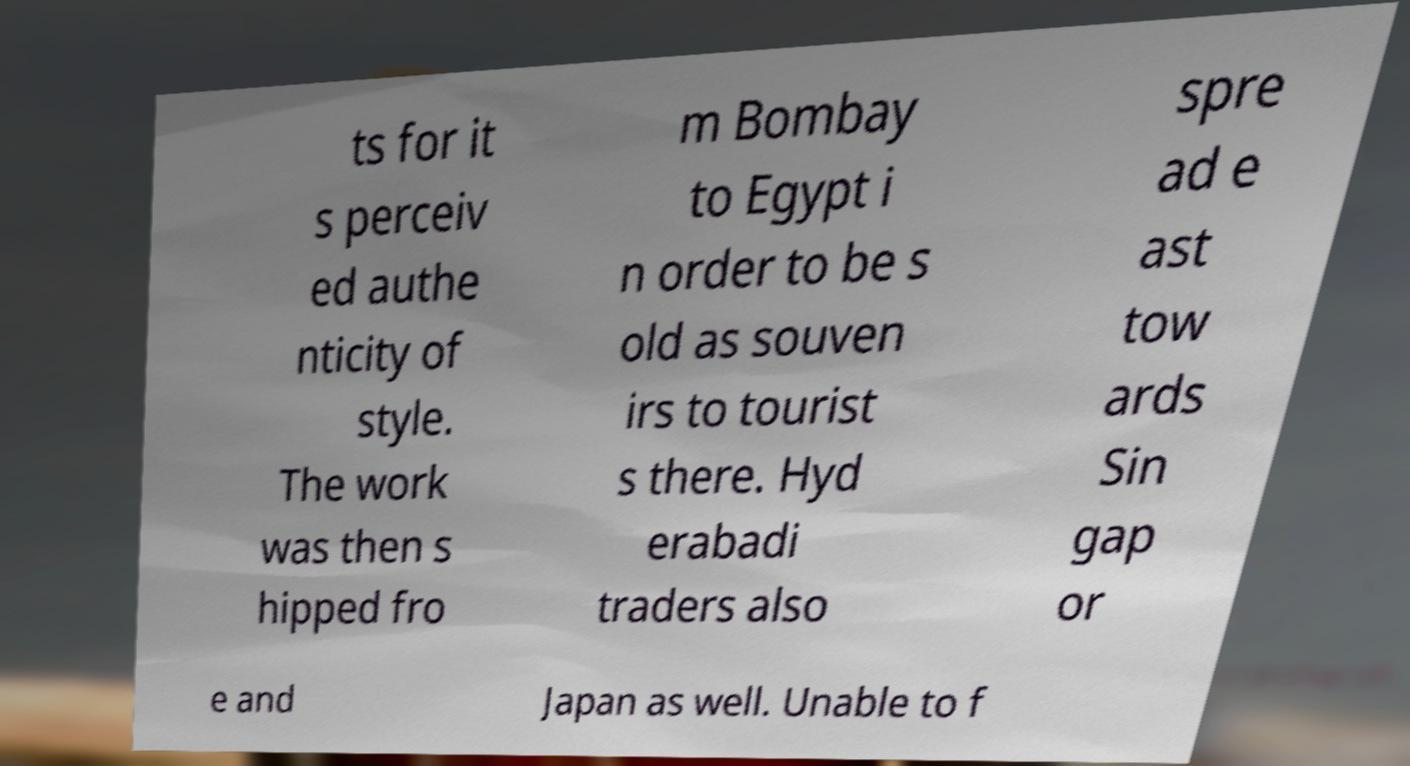Could you assist in decoding the text presented in this image and type it out clearly? ts for it s perceiv ed authe nticity of style. The work was then s hipped fro m Bombay to Egypt i n order to be s old as souven irs to tourist s there. Hyd erabadi traders also spre ad e ast tow ards Sin gap or e and Japan as well. Unable to f 